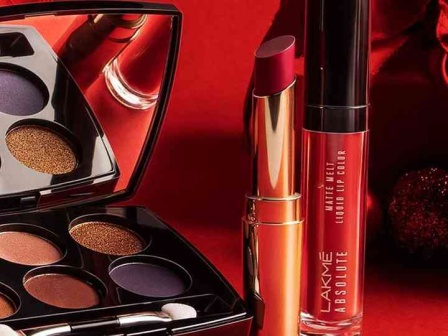Write a detailed description of the given image. The image showcases an eye-catching display of three makeup products from the renowned brand Lakme, set against a bold red background. At the center of the composition, an open eyeshadow palette reveals six distinct shades. Three of these shades shimmer with a stunning golden hue, while the other three are a captivating royal purple. To the left of the palette, a lipstick with a vibrant metallic orange color stands out, bringing a burst of brightness to the scene. On the right side, a bottle of liquid lip color in a deep, rich red tone adds to the luxurious feel. The brand 'Lakme' is clearly displayed in white text on each product, emphasizing their premium quality. The arrangement and vivid color contrast create a visually captivating composition that highlights the diverse and high-quality makeup products offered by Lakme. 